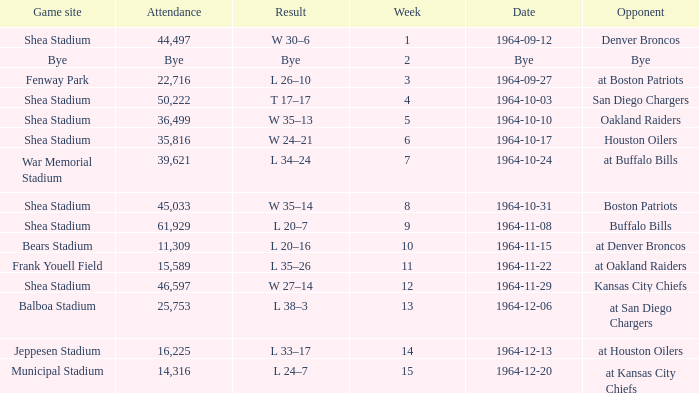What's the outcome for week 15? L 24–7. 